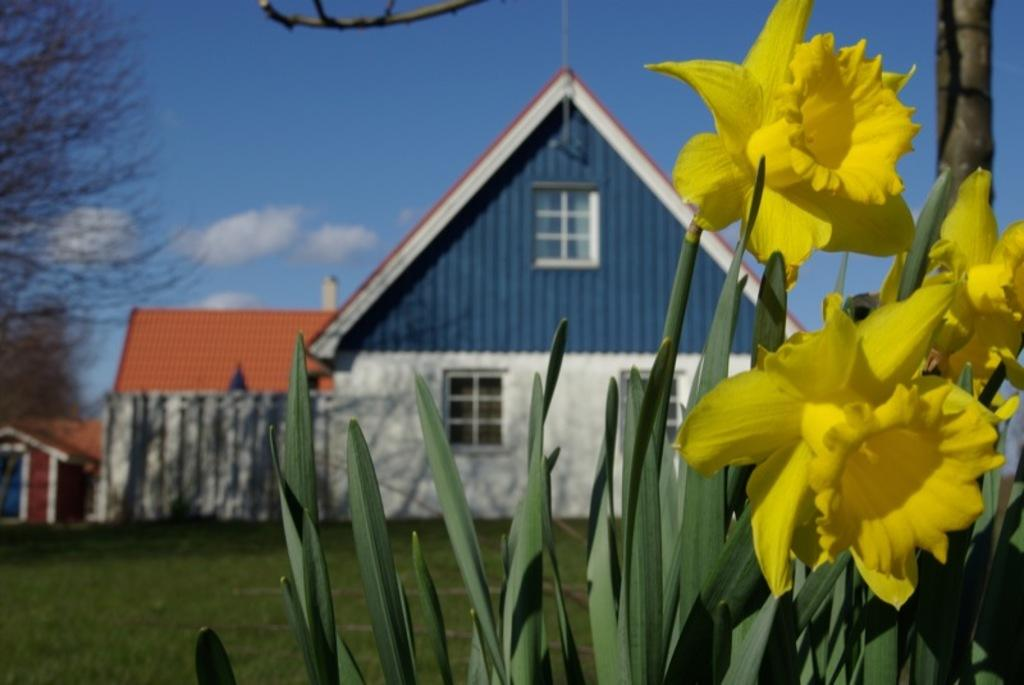What type of living organisms can be seen in the image? Plants and flowers are visible in the image. What color are the plants in the image? The plants are green in color. What color are the flowers in the image? The flowers are yellow in color. What can be seen in the background of the image? Grass, buildings, a tree, and the sky are visible in the background of the image. What type of bait is being used to catch fish in the image? There is no mention of fish or bait in the image; it features plants, flowers, and background elements. Can you see a plane flying in the sky in the image? There is no plane visible in the sky in the image. 